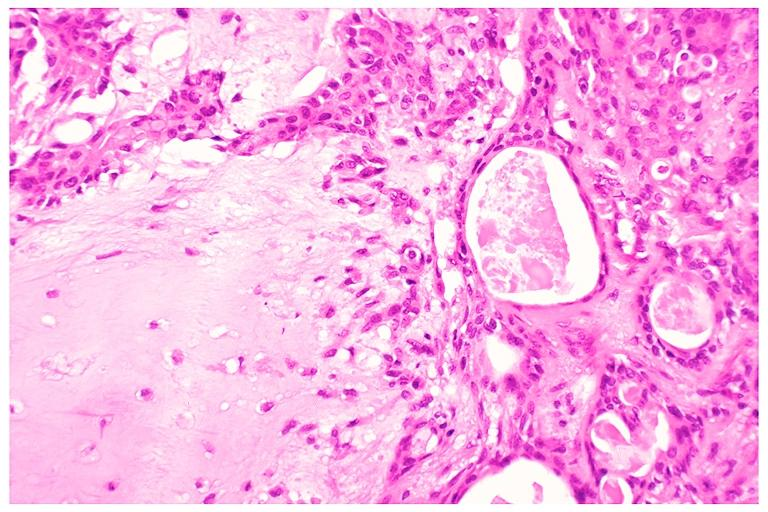what does this image show?
Answer the question using a single word or phrase. Pleomorphic adenoma benign mixed tumor 